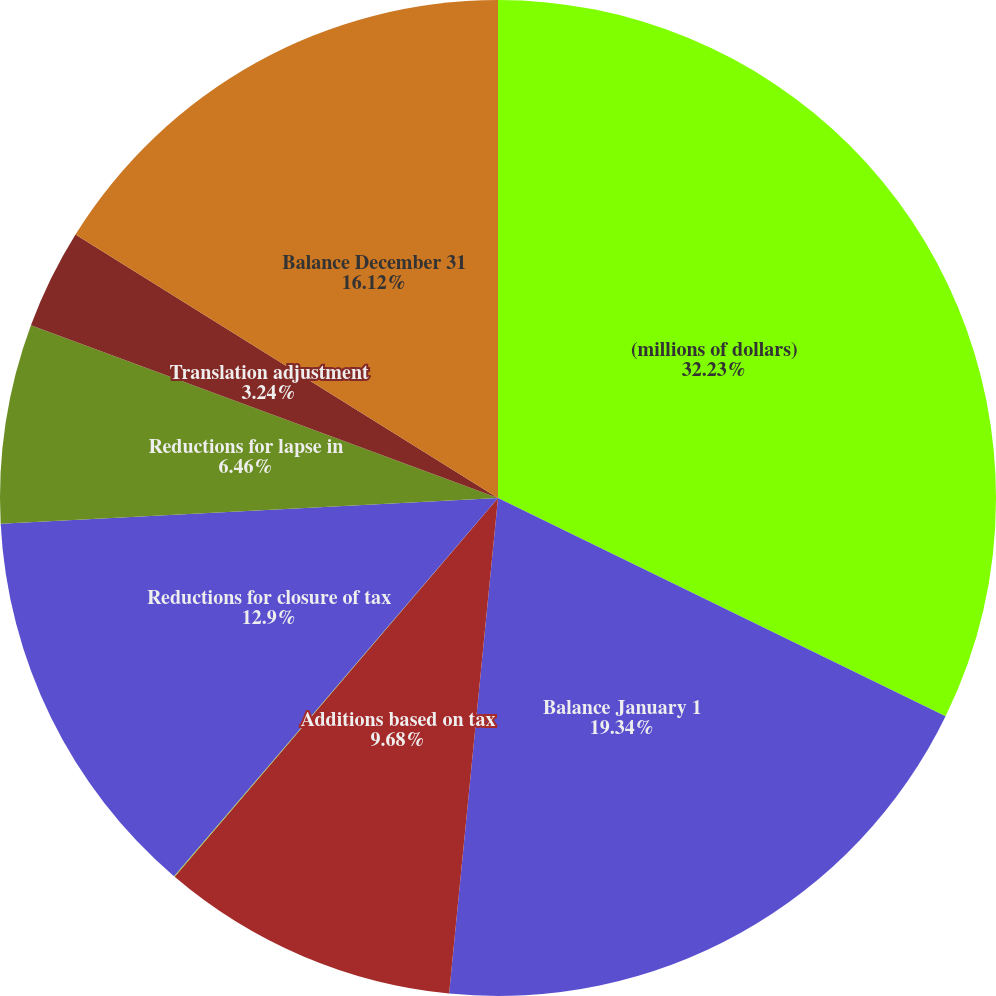Convert chart to OTSL. <chart><loc_0><loc_0><loc_500><loc_500><pie_chart><fcel>(millions of dollars)<fcel>Balance January 1<fcel>Additions based on tax<fcel>Additions/(reductions) for tax<fcel>Reductions for closure of tax<fcel>Reductions for lapse in<fcel>Translation adjustment<fcel>Balance December 31<nl><fcel>32.22%<fcel>19.34%<fcel>9.68%<fcel>0.03%<fcel>12.9%<fcel>6.46%<fcel>3.24%<fcel>16.12%<nl></chart> 